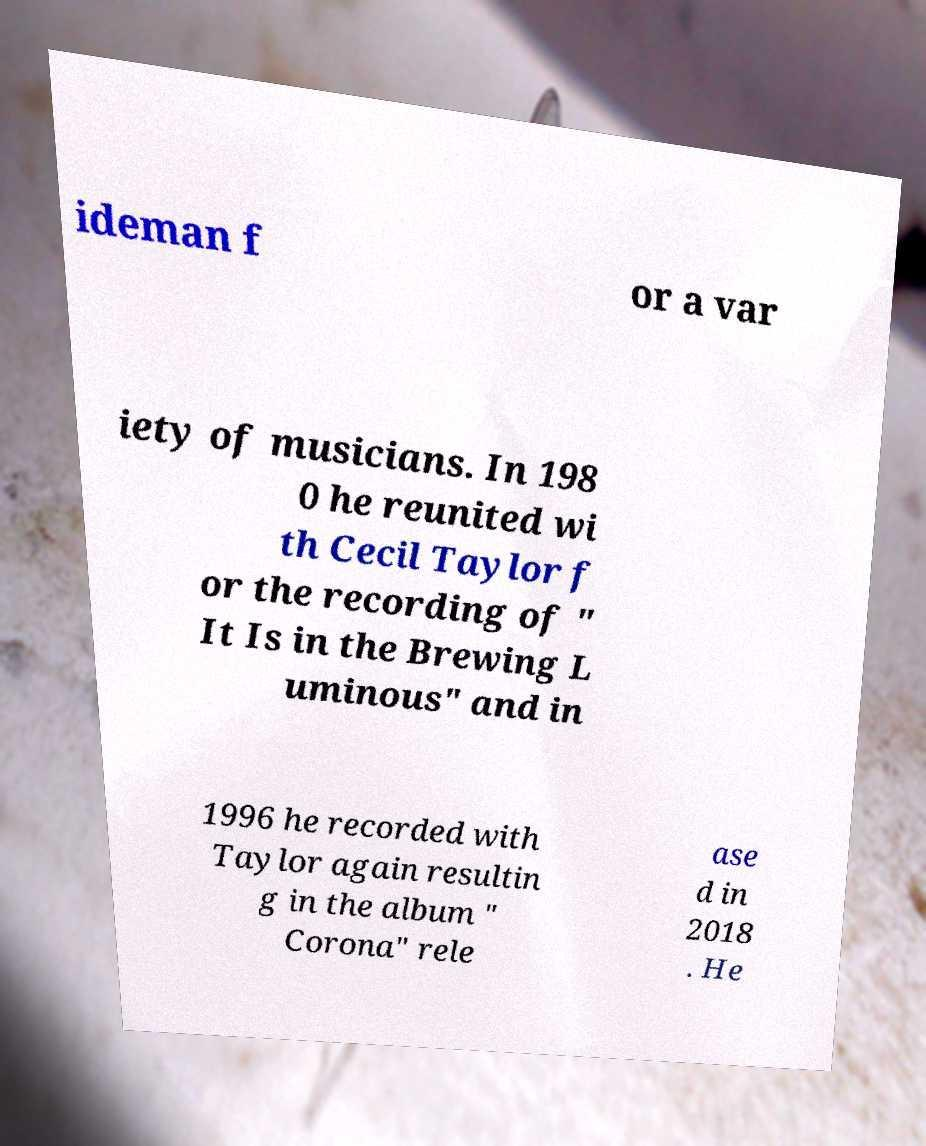There's text embedded in this image that I need extracted. Can you transcribe it verbatim? ideman f or a var iety of musicians. In 198 0 he reunited wi th Cecil Taylor f or the recording of " It Is in the Brewing L uminous" and in 1996 he recorded with Taylor again resultin g in the album " Corona" rele ase d in 2018 . He 